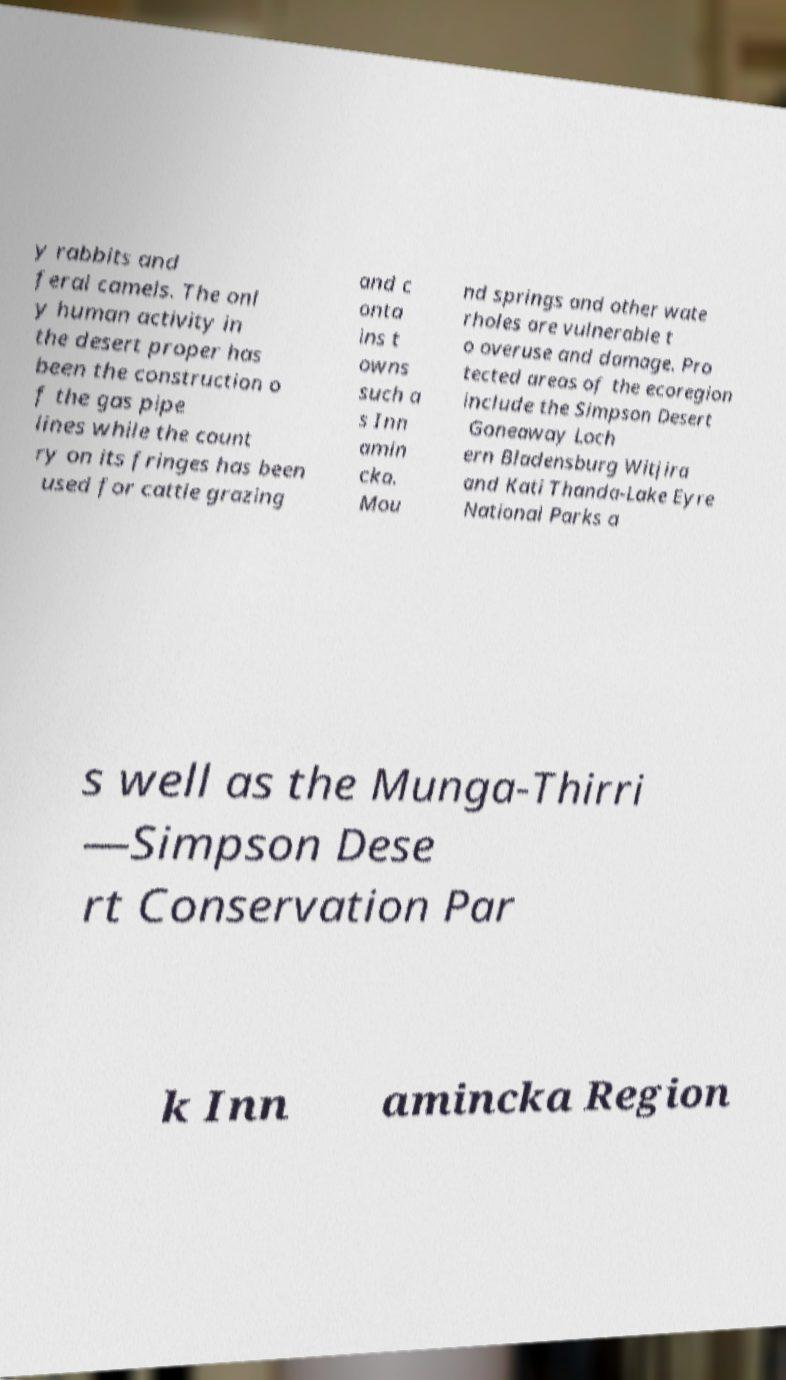I need the written content from this picture converted into text. Can you do that? y rabbits and feral camels. The onl y human activity in the desert proper has been the construction o f the gas pipe lines while the count ry on its fringes has been used for cattle grazing and c onta ins t owns such a s Inn amin cka. Mou nd springs and other wate rholes are vulnerable t o overuse and damage. Pro tected areas of the ecoregion include the Simpson Desert Goneaway Loch ern Bladensburg Witjira and Kati Thanda-Lake Eyre National Parks a s well as the Munga-Thirri —Simpson Dese rt Conservation Par k Inn amincka Region 